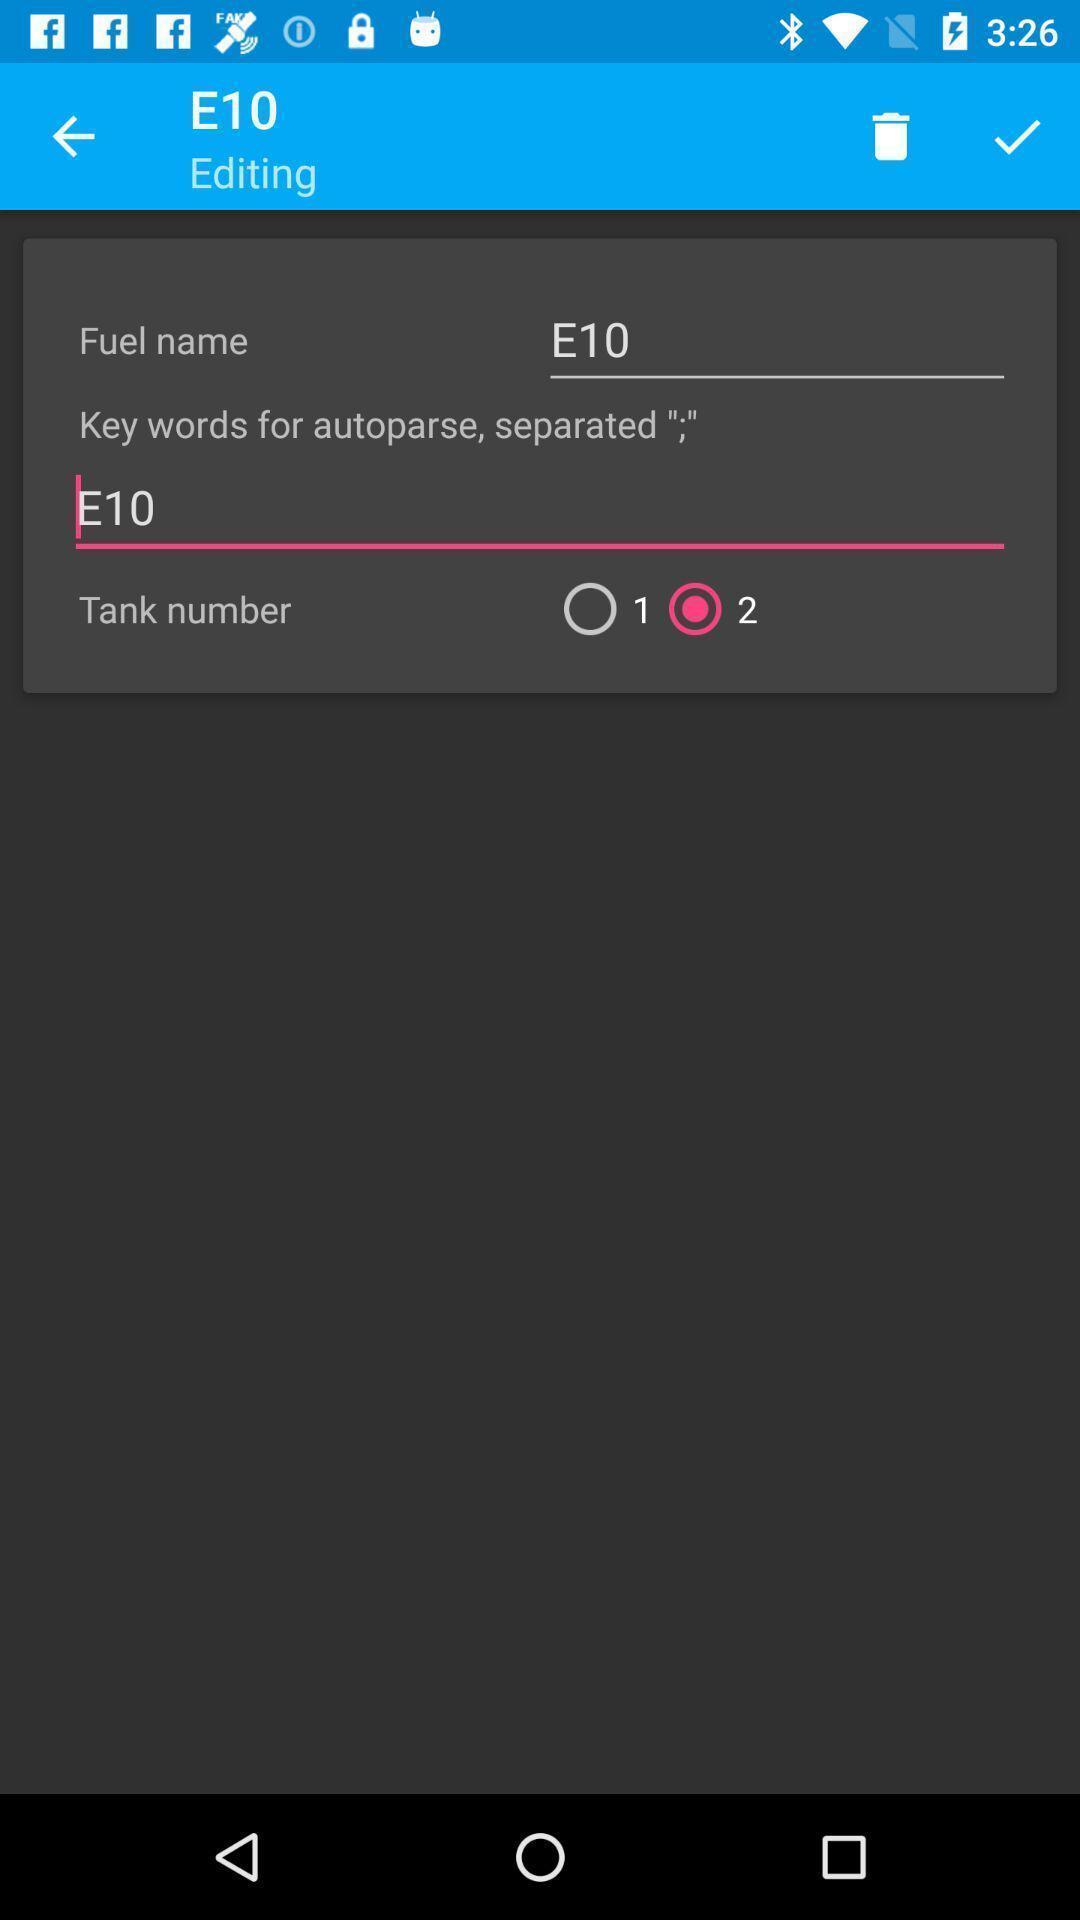What details can you identify in this image? Screen displaying dual-fuel consumption calculation of fuel. 